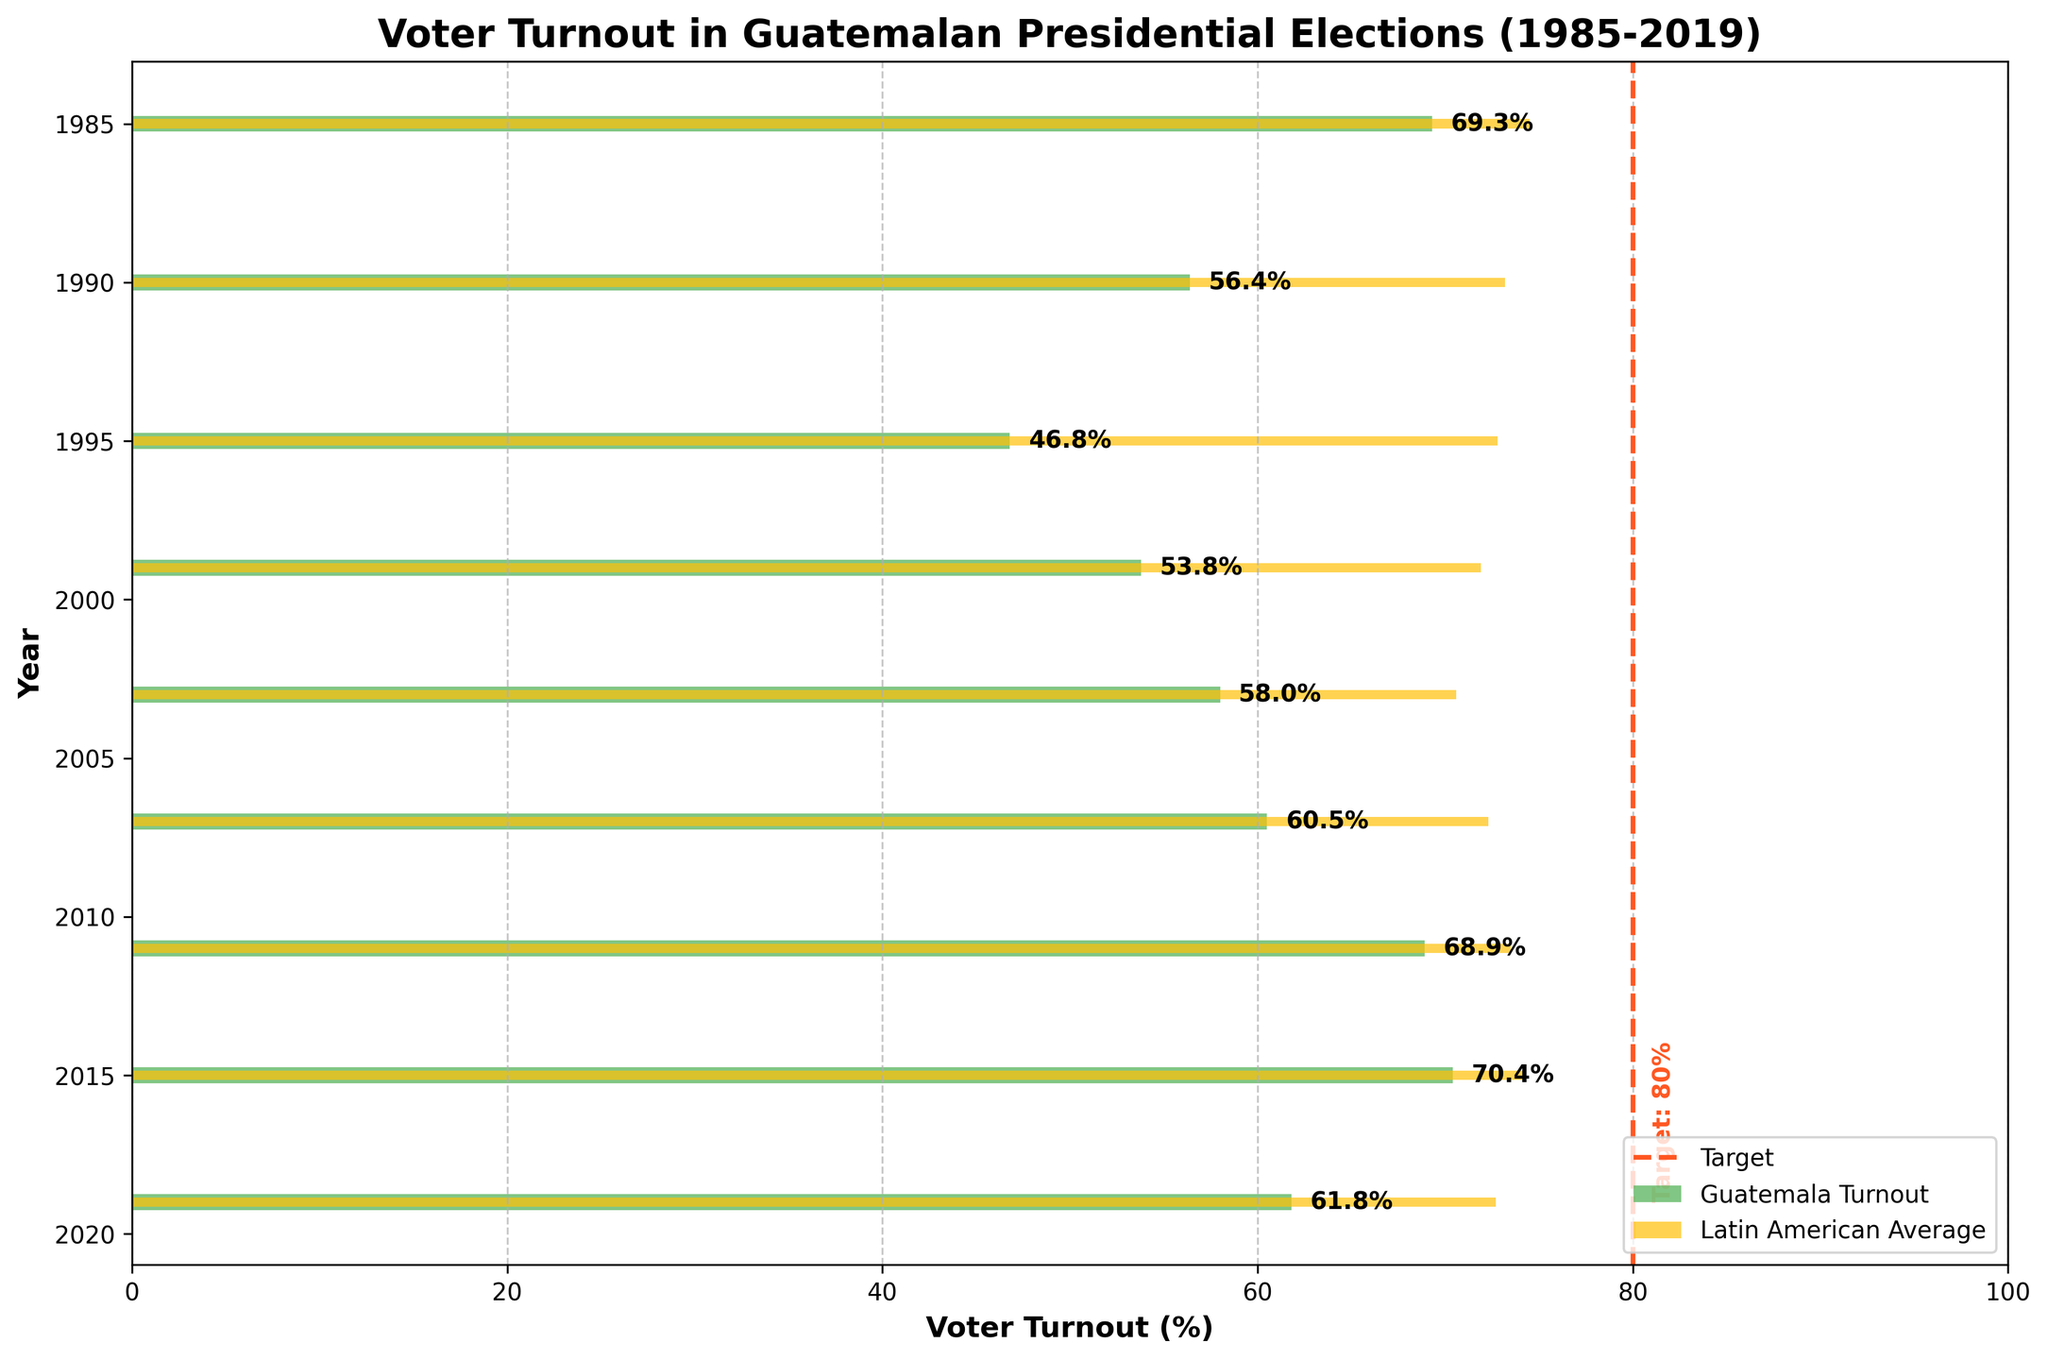What is the title of the chart? The title is located at the top of the chart and summarizes the chart's content, which is voter turnout in Guatemalan presidential elections from 1985 to 2019.
Answer: Voter Turnout in Guatemalan Presidential Elections (1985-2019) What was the voter turnout in Guatemala in 2011? The turnout for each specific year is marked by the bar's endpoint and explicitly labeled next to the bar. Look for the label next to the "2011" bar.
Answer: 68.9% Which year had the lowest voter turnout in Guatemala? Compare the lengths of the green bars; the shortest bar will indicate the lowest turnout. Identify the year associated with this bar.
Answer: 1995 How does the voter turnout in 2015 compare with the Latin American average for the same year? Locate the bars for 2015, one green and one yellow. Compare the lengths of the bars or use the label values.
Answer: Higher; Guatemala: 70.4%, Latin American Average: 74.1% In which years did Guatemala's voter turnout meet or exceed 60%? Check the green bars and their labels to see if they reach or pass the 60% mark and note the corresponding years.
Answer: 1985, 2007, 2011, 2015 Was Guatemala's voter turnout ever higher than the Latin American average? Check if any green bar surpasses the yellow bar in length in any year and confirm with the labeled values.
Answer: Yes, in 2015 What is the target voter turnout indicated in the chart? Identify the vertical dashed line and its associated label at the end of the chart.
Answer: 80% How many years had a voter turnout under 60% in Guatemala? Count the green bars that ended below the 60% mark.
Answer: Four years (1990, 1995, 1999, 2019) Which year had the closest voter turnout to the target? Find the green bar that is nearest to the vertical dashed line, either by visual approximation or comparing numerical values.
Answer: 2015 